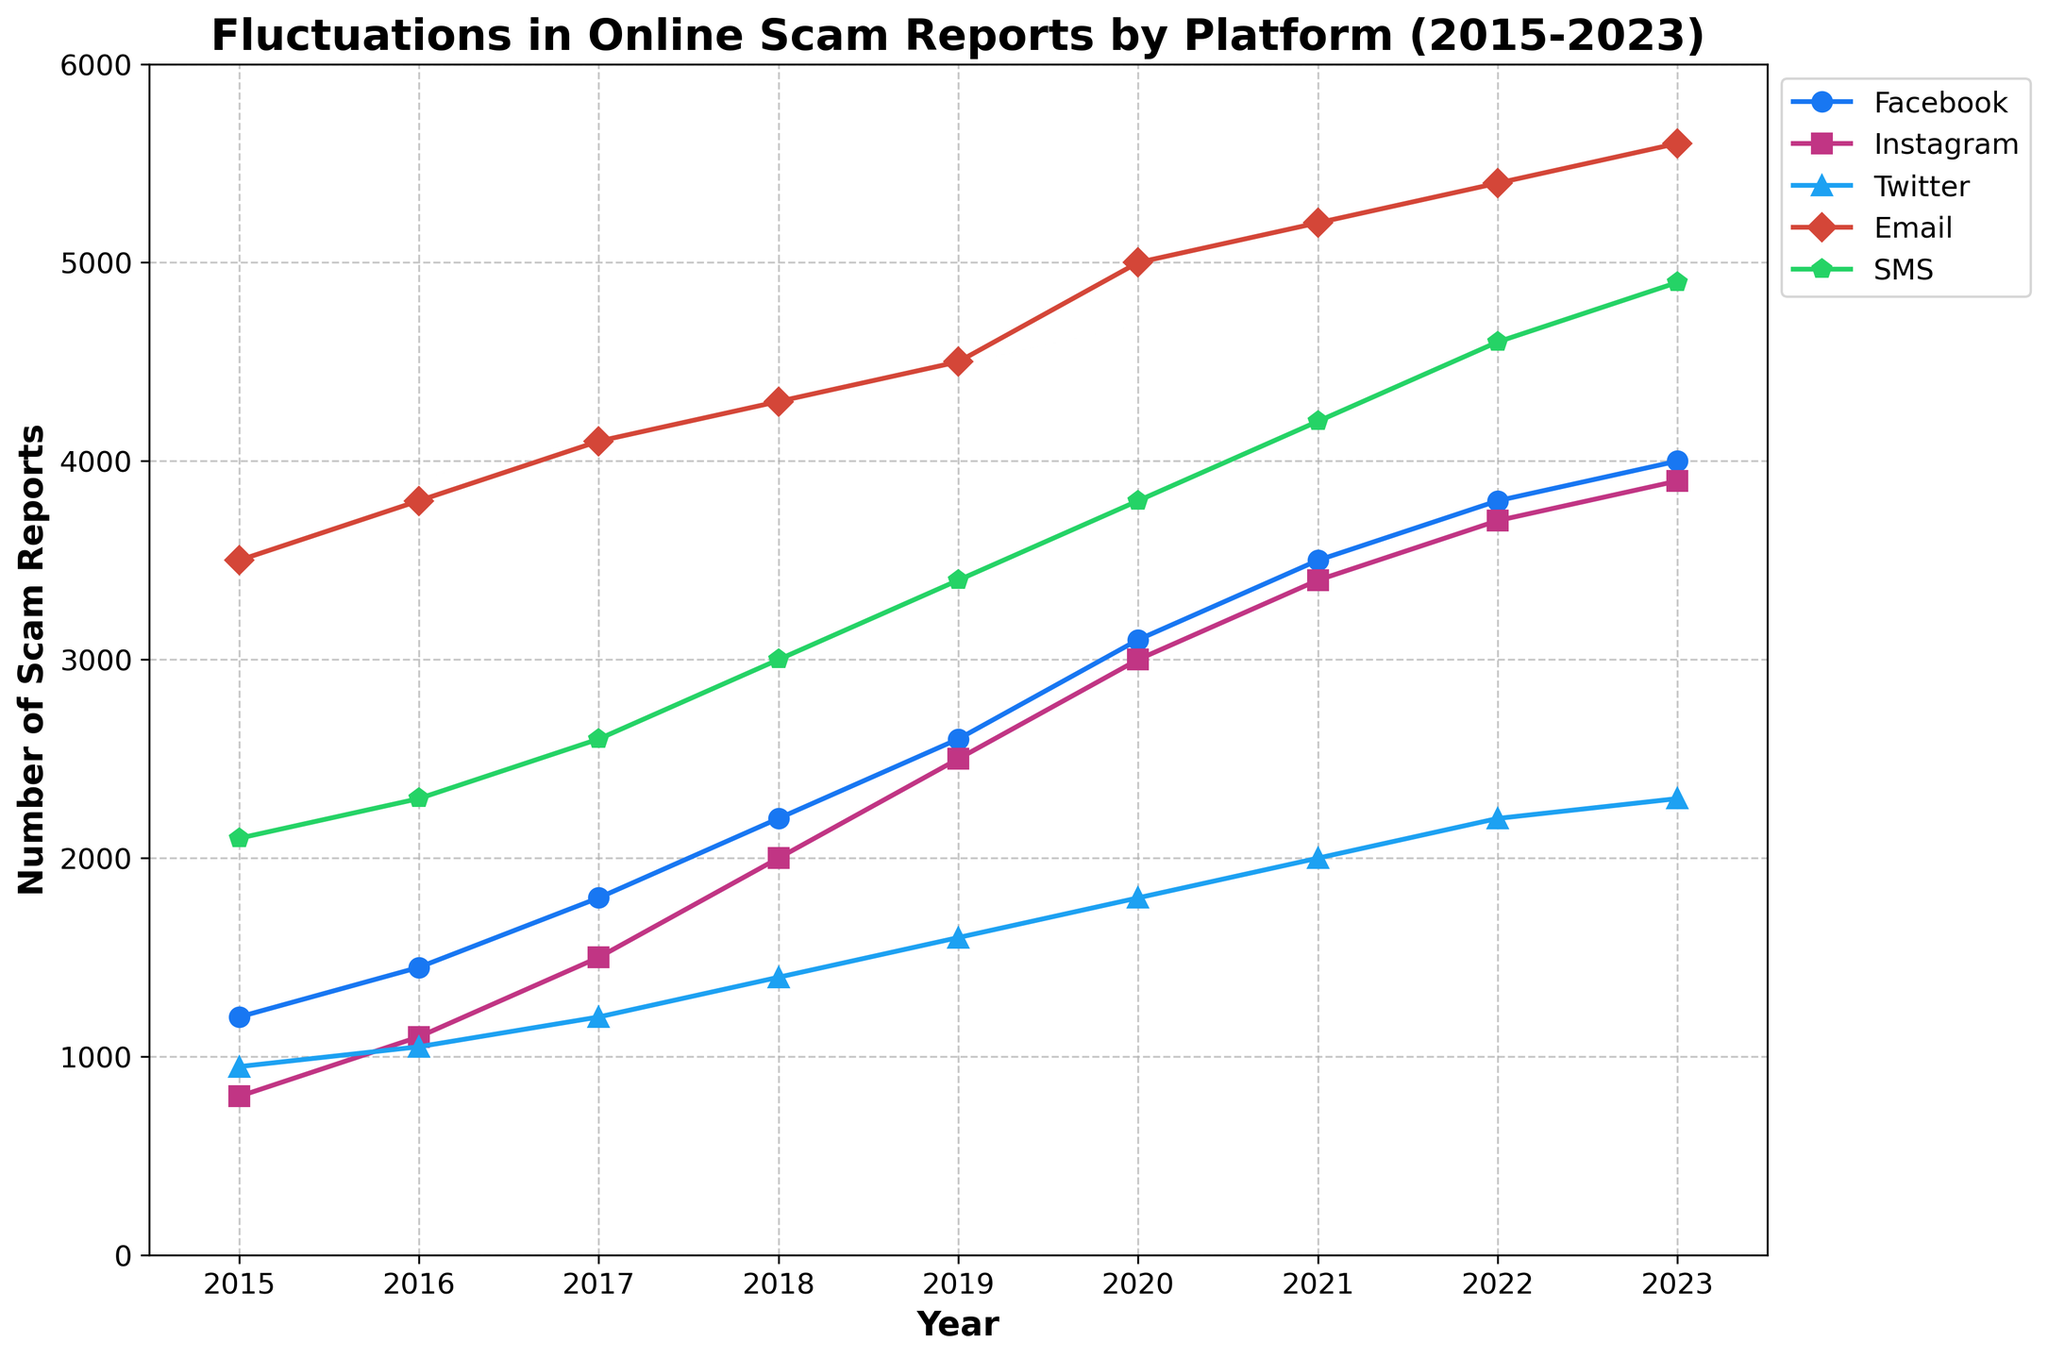Which platform had the highest number of scam reports in 2023? First, look at the plotted lines for each platform for the year 2023. The Email line reaches the highest point for that year.
Answer: Email Which year did reports on Facebook surpass those on Instagram for the first time? Compare the plotted lines for Facebook and Instagram year by year. Facebook reports first surpass Instagram reports in 2022.
Answer: 2022 What is the difference in the number of scam reports between SMS and Twitter in 2018? Look at the plotted points for SMS and Twitter in 2018. SMS has 3000 reports, and Twitter has 1400 reports. The difference is 3000 - 1400 = 1600.
Answer: 1600 Which platform shows the most stable trend from 2015 to 2023? Examine the plotted lines for all platforms. Twitter shows the least fluctuation and gradual increase compared to the others.
Answer: Twitter By how much did the total number of reports for all platforms increase from 2015 to 2023? Sum the reports for all platforms in 2015 (1200 + 800 + 950 + 3500 + 2100 = 8550) and in 2023 (4000 + 3900 + 2300 + 5600 + 4900 = 20700). The increase is 20700 - 8550 = 12150.
Answer: 12150 In which year did scam reports on Email platforms see the largest increase from the previous year? Calculate the year-over-year increases for Email. The largest increase is from 2020 (5000) to 2021 (5200), which is 5200 - 5000 = 200.
Answer: 2021 How many more reports did Facebook receive compared to Instagram in 2019? Look at the plotted points for Facebook and Instagram in 2019. Facebook has 2600 reports, and Instagram has 2500 reports. The difference is 2600 - 2500 = 100.
Answer: 100 What is the average number of scam reports for Instagram over the years? Sum the reports for Instagram from 2015 to 2023 (800 + 1100 + 1500 + 2000 + 2500 + 3000 + 3400 + 3700 + 3900 = 21900) and divide by the number of years (9). The average is 21900 / 9 ≈ 2433.
Answer: 2433 